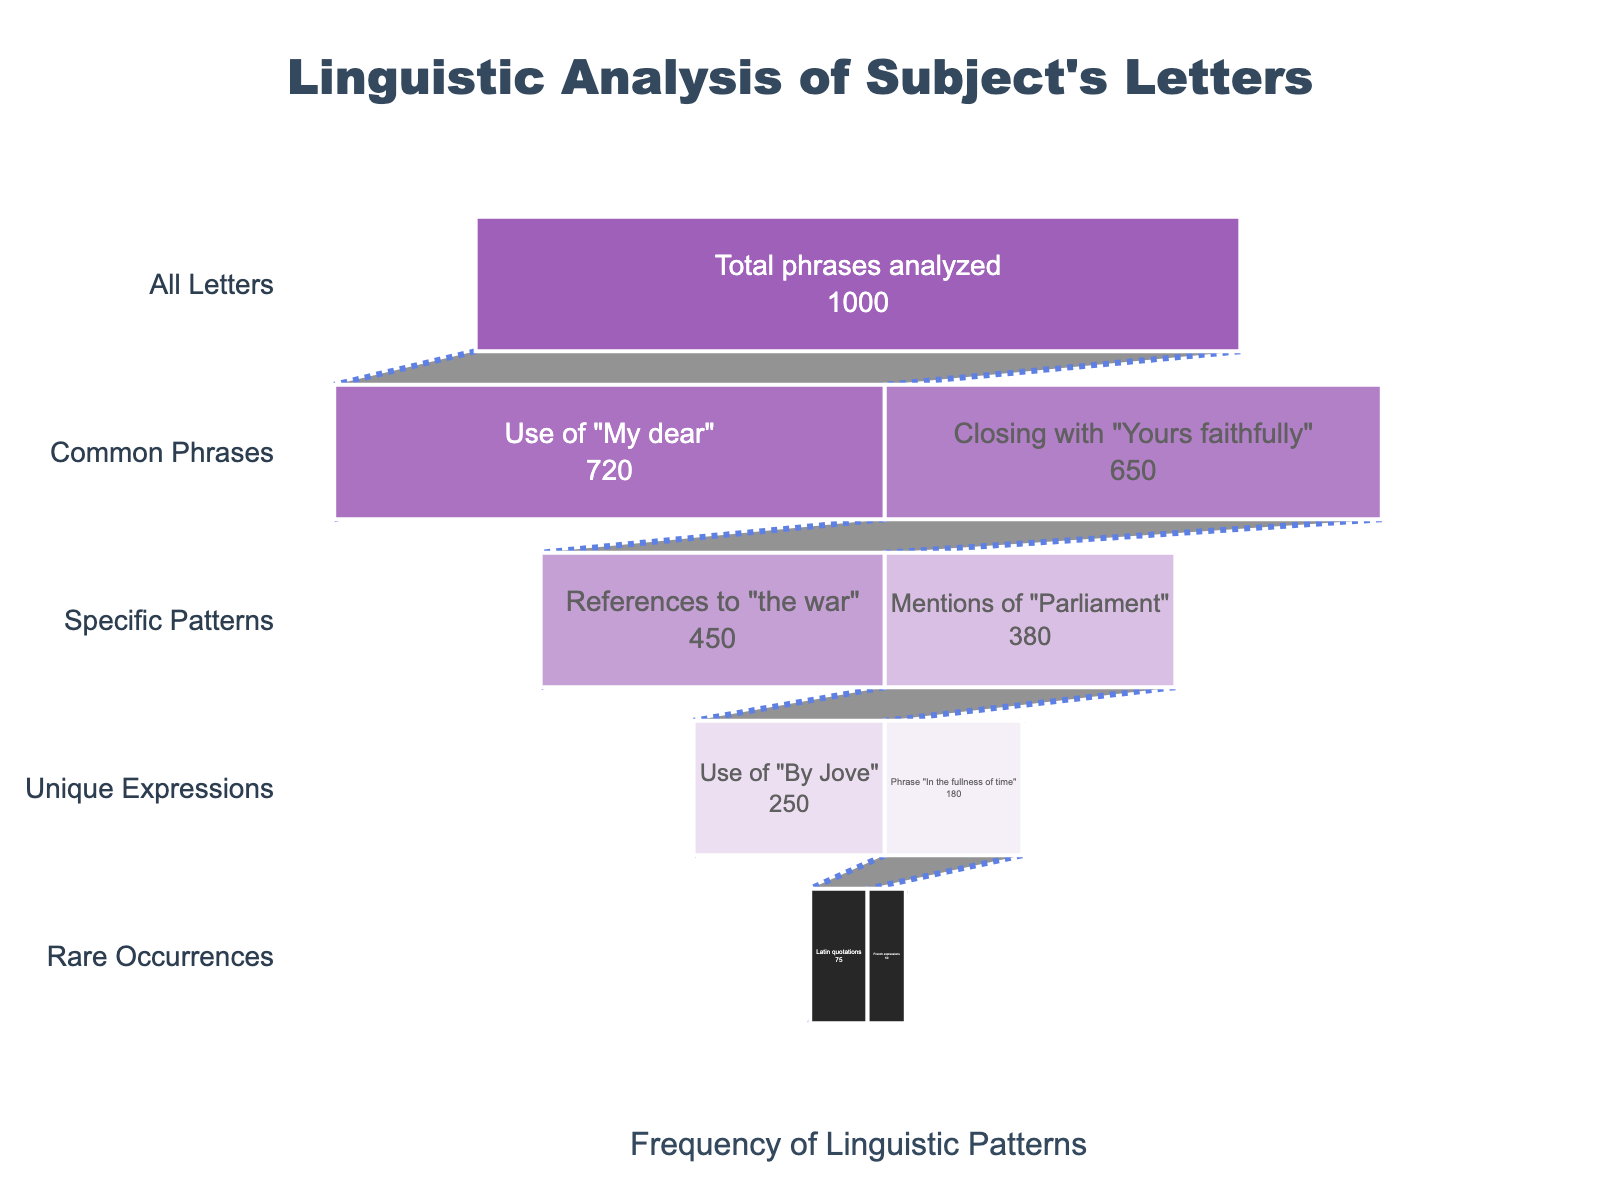what is the total number of linguistic phrases analyzed? According to the funnel chart, the total number of linguistic phrases analyzed is at the 'All Letters' stage, which is the first stage in the funnel and represents the broadest category.
Answer: 1000 Which phrase has the highest frequency? From the chart, the phrase "Use of 'My dear'" has the highest frequency, located within the 'Common Phrases' stage and has a value of 720.
Answer: Use of 'My dear' How many stages are there in the funnel chart? By observing the funnel chart, there are four distinct stages: All Letters, Common Phrases, Specific Patterns, and Unique Expressions, and Rare Occurrences.
Answer: Four What is the combined frequency of phrases in the 'Common Phrases' stage? In the 'Common Phrases' stage, the frequencies are 720 for "Use of 'My dear'" and 650 for "Closing with 'Yours faithfully'". Adding these gives 720 + 650 = 1370.
Answer: 1370 Which phrase is most frequent in the 'Specific Patterns' stage? In the 'Specific Patterns' stage, the phrases "References to 'the war'" and "Mentions of 'Parliament'" have frequencies of 450 and 380 respectively. The most frequent is "References to 'the war'".
Answer: References to 'the war' How much more frequent is "References to 'the war'" compared to "Mentions of 'Parliament'"? The frequency of "References to 'the war'" is 450, while "Mentions of 'Parliament'" is 380. Therefore, the difference is 450 - 380 = 70.
Answer: 70 Which stage includes Latin quotations and French expressions? Observing the funnel stages, Latin quotations and French expressions both fall under the 'Rare Occurrences' stage.
Answer: Rare Occurrences What percentage of total phrases does "Use of 'By Jove'" represent? "Use of 'By Jove'" has a frequency of 250. The total phrases analyzed are 1000. Therefore, the percentage is (250/1000)*100 = 25%.
Answer: 25% How many more phrases are there in the 'Specific Patterns' stage compared to the 'Unique Expressions' stage? The frequencies in 'Specific Patterns' are 450 and 380, totaling 830. The frequencies in 'Unique Expressions' are 250 and 180, totaling 430. The difference is 830 - 430 = 400.
Answer: 400 What unique phrase is less frequent: "In the fullness of time" or "Use of 'By Jove'"? In the 'Unique Expressions' stage, "In the fullness of time" has a frequency of 180, while "Use of 'By Jove'" has a frequency of 250. Therefore, "In the fullness of time" is less frequent.
Answer: In the fullness of time 